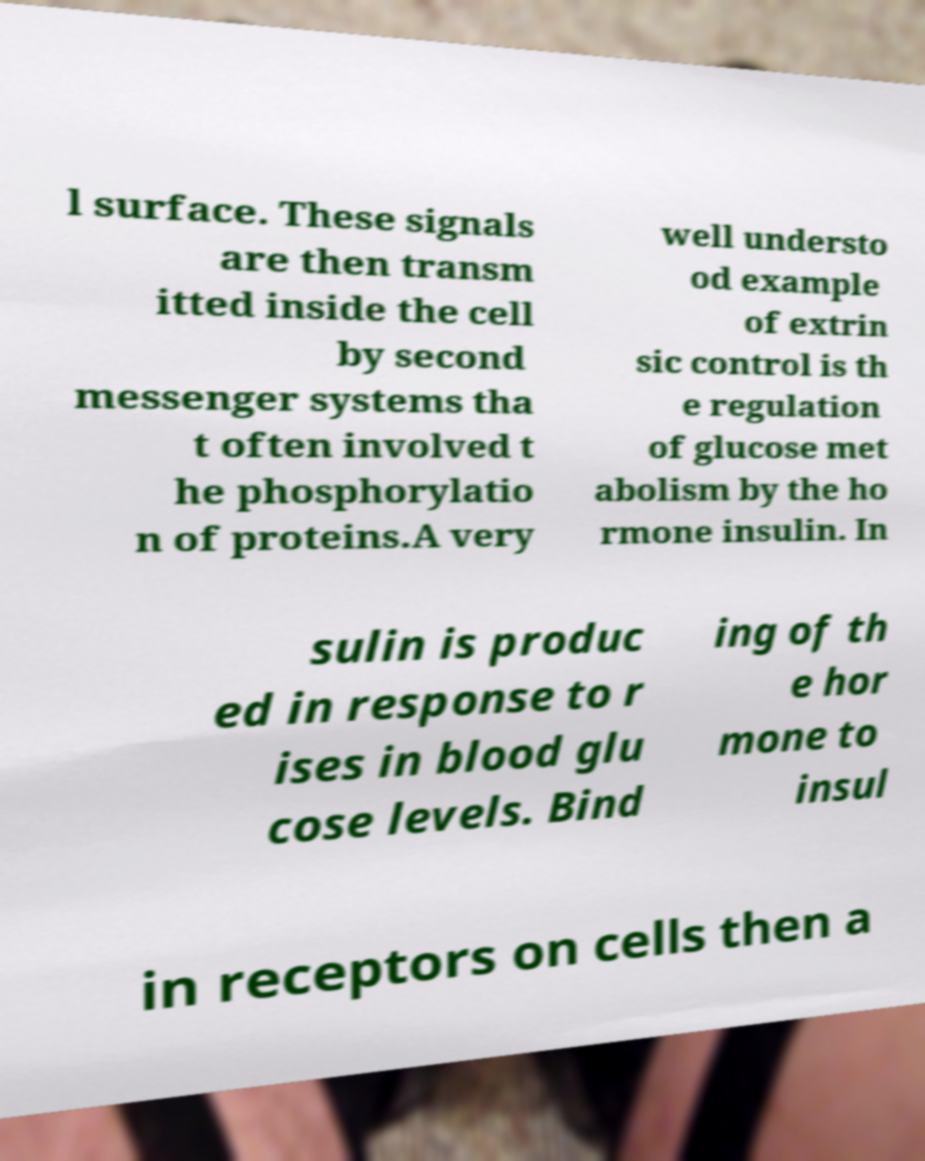I need the written content from this picture converted into text. Can you do that? l surface. These signals are then transm itted inside the cell by second messenger systems tha t often involved t he phosphorylatio n of proteins.A very well understo od example of extrin sic control is th e regulation of glucose met abolism by the ho rmone insulin. In sulin is produc ed in response to r ises in blood glu cose levels. Bind ing of th e hor mone to insul in receptors on cells then a 